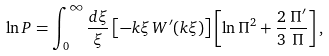<formula> <loc_0><loc_0><loc_500><loc_500>\ln P = \int _ { 0 } ^ { \infty } \frac { d \xi } { \xi } \left [ - k \xi \, W ^ { \prime } ( k \xi ) \right ] \left [ \ln \Pi ^ { 2 } + \frac { 2 } { 3 } \frac { \Pi ^ { \prime } } { \Pi } \right ] ,</formula> 